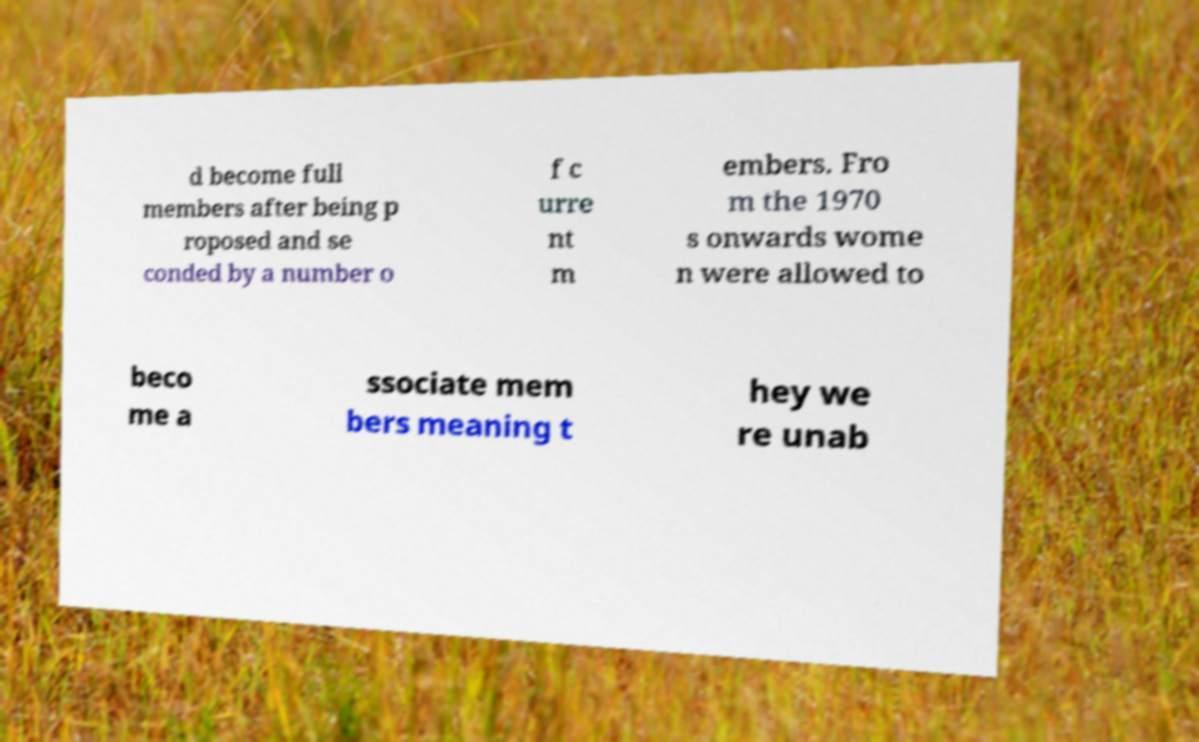There's text embedded in this image that I need extracted. Can you transcribe it verbatim? d become full members after being p roposed and se conded by a number o f c urre nt m embers. Fro m the 1970 s onwards wome n were allowed to beco me a ssociate mem bers meaning t hey we re unab 